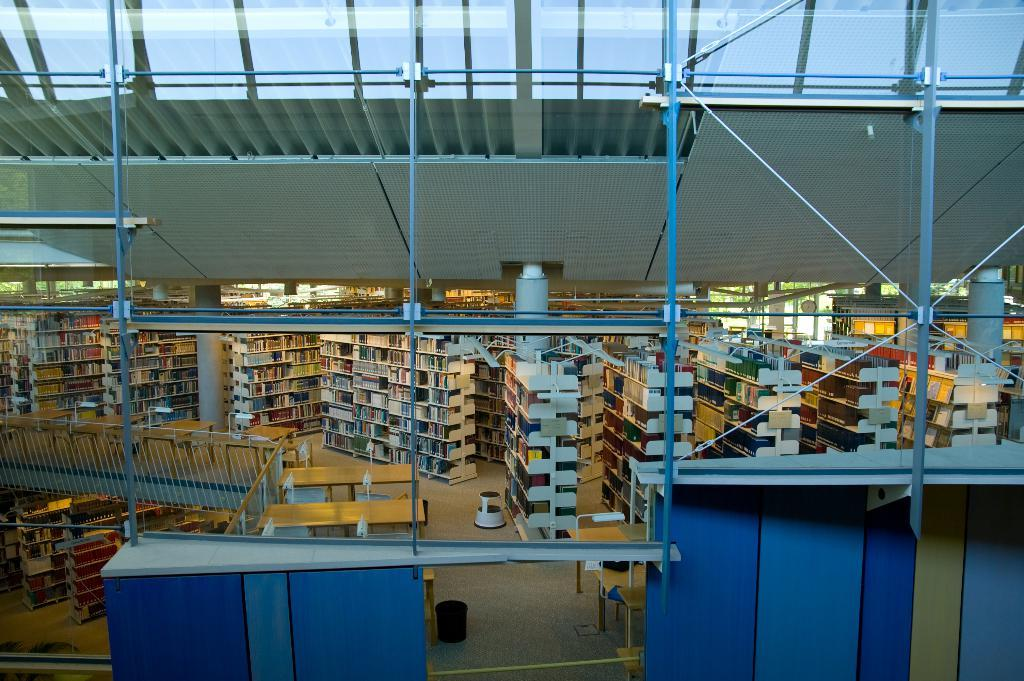What type of objects can be seen on the shelves in the image? There are books on the shelves in the image. What type of furniture is present in the image? There are tables in the image. Can you describe the arrangement of the books and tables in the image? The books are on the shelves, and the tables are likely nearby or in the same room. What type of stone is used to build the trucks in the image? There are no trucks present in the image, so it is not possible to determine what type of stone might be used to build them. 